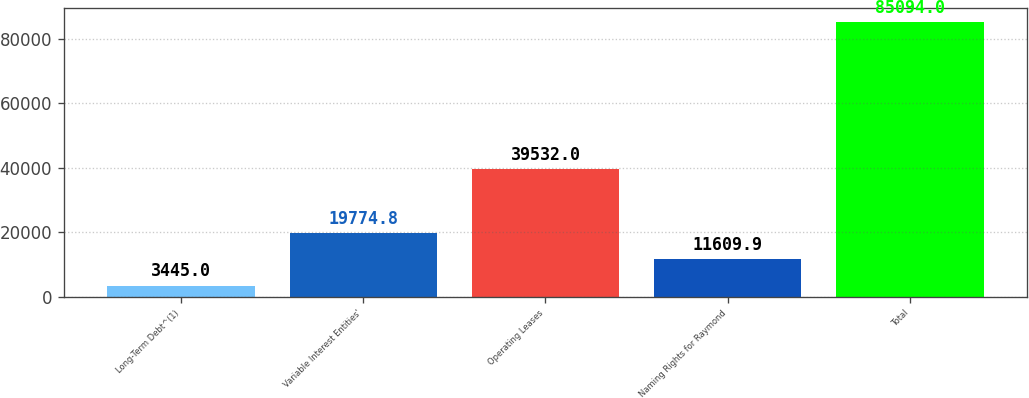Convert chart. <chart><loc_0><loc_0><loc_500><loc_500><bar_chart><fcel>Long-Term Debt^(1)<fcel>Variable Interest Entities'<fcel>Operating Leases<fcel>Naming Rights for Raymond<fcel>Total<nl><fcel>3445<fcel>19774.8<fcel>39532<fcel>11609.9<fcel>85094<nl></chart> 